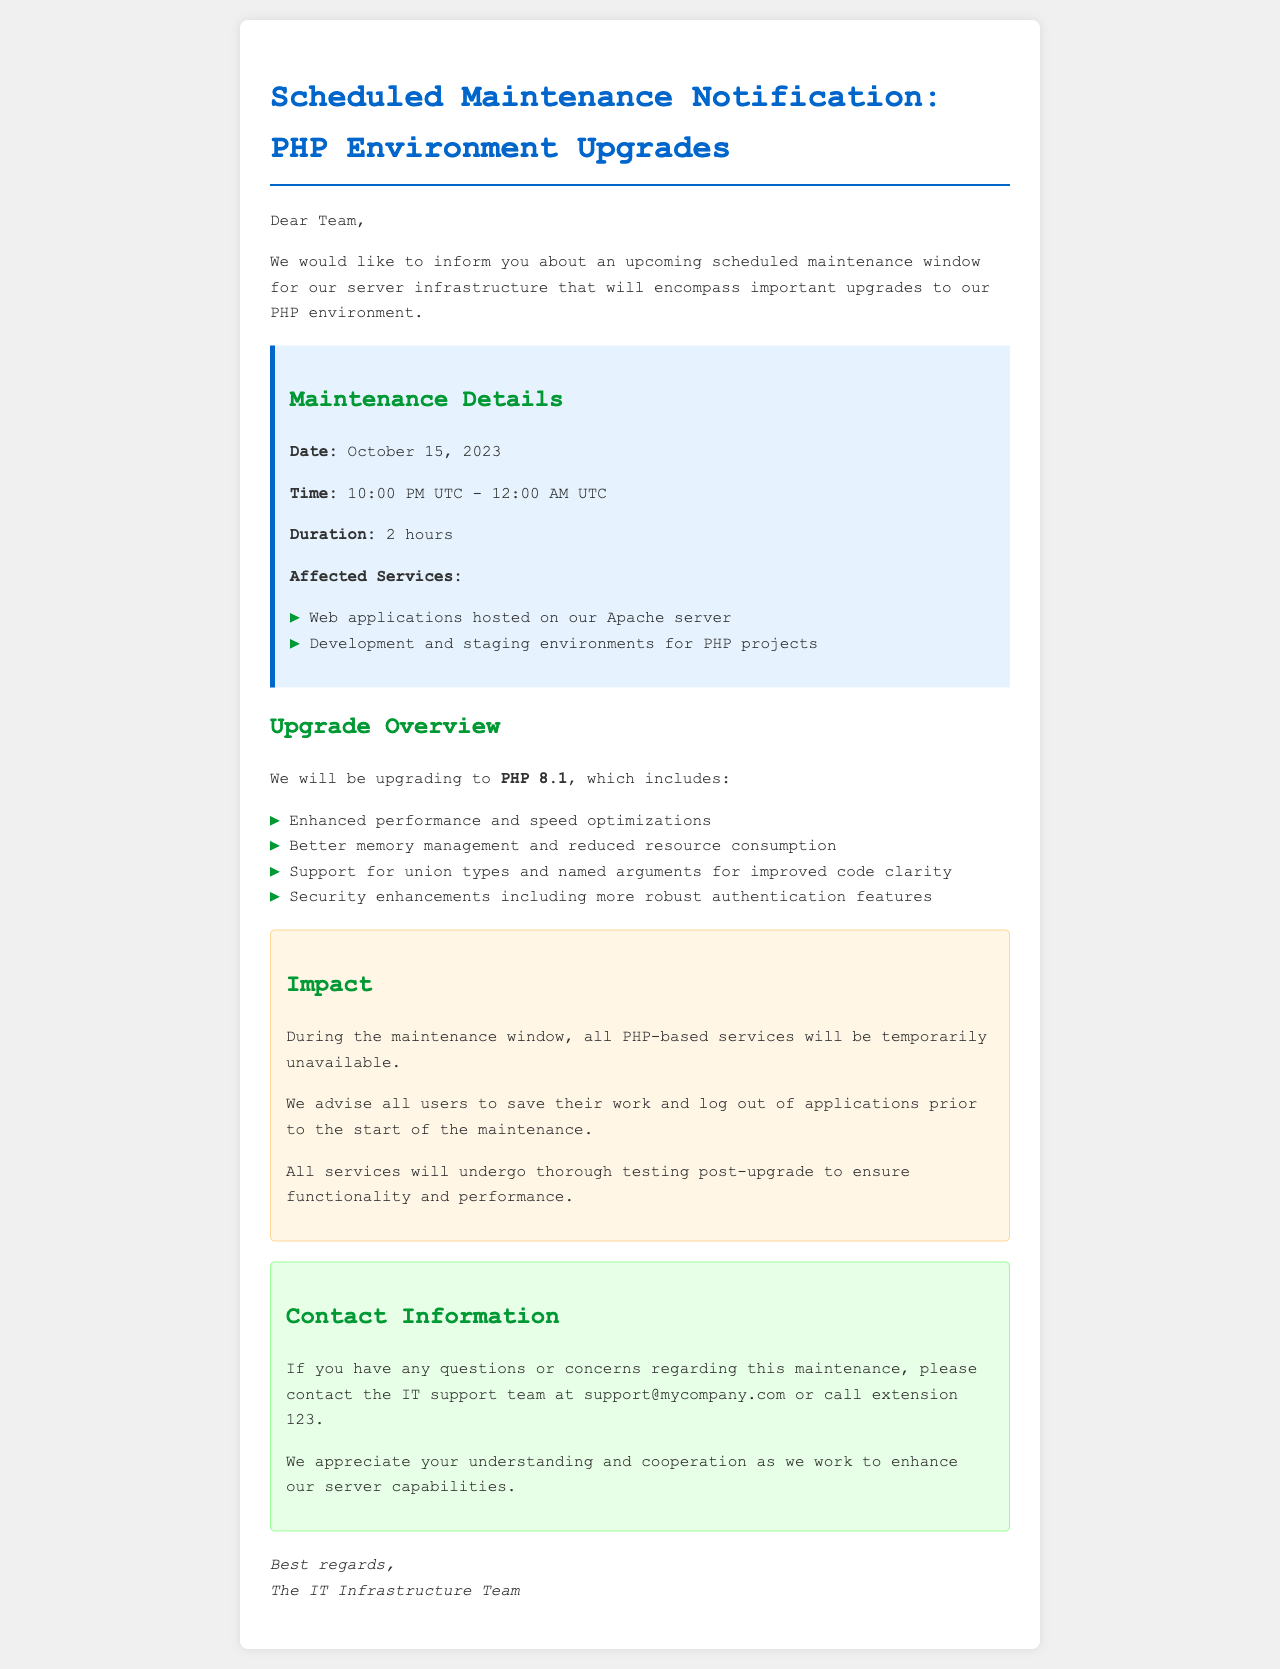What is the date of the scheduled maintenance? The date of the scheduled maintenance is clearly stated in the document.
Answer: October 15, 2023 What is the duration of the maintenance? The duration is indicated in the maintenance details section of the document.
Answer: 2 hours What is the time window for the maintenance? The time is specified in the maintenance details, providing the start and end times.
Answer: 10:00 PM UTC - 12:00 AM UTC Which PHP version will be upgraded to? The document mentions the specific PHP version being upgraded.
Answer: PHP 8.1 What types of environments are affected by the maintenance? The affected services are listed in the maintenance details section.
Answer: Web applications, Development and staging environments What should users do before the maintenance starts? The document advises users on actions they should take before maintenance begins.
Answer: Save their work and log out What impact will the maintenance have on services? The impact is summarized in a dedicated section about the maintenance.
Answer: All PHP-based services will be temporarily unavailable Who should be contacted for questions about the maintenance? Contact information is provided in the document for inquiries about the maintenance.
Answer: IT support team at support@mycompany.com 